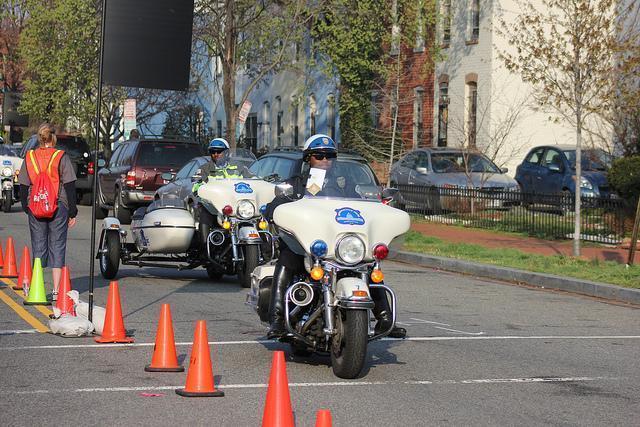How many yellow cones are there?
Give a very brief answer. 1. How many motorcycles are in the picture?
Give a very brief answer. 2. How many people are in the picture?
Give a very brief answer. 2. How many cars are in the photo?
Give a very brief answer. 3. How many bowls have eggs?
Give a very brief answer. 0. 